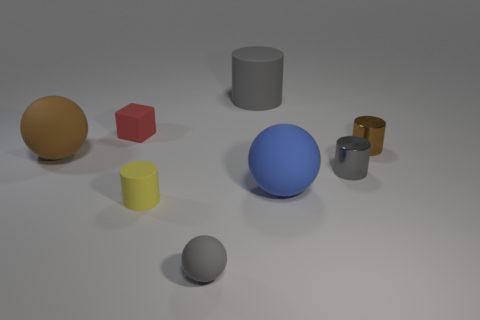Are any tiny yellow rubber cylinders visible? Yes, there is a tiny yellow cylinder visible among other geometric shapes, slightly to the left of the center of the image, resting on a grey surface with a shadow cast under it. 